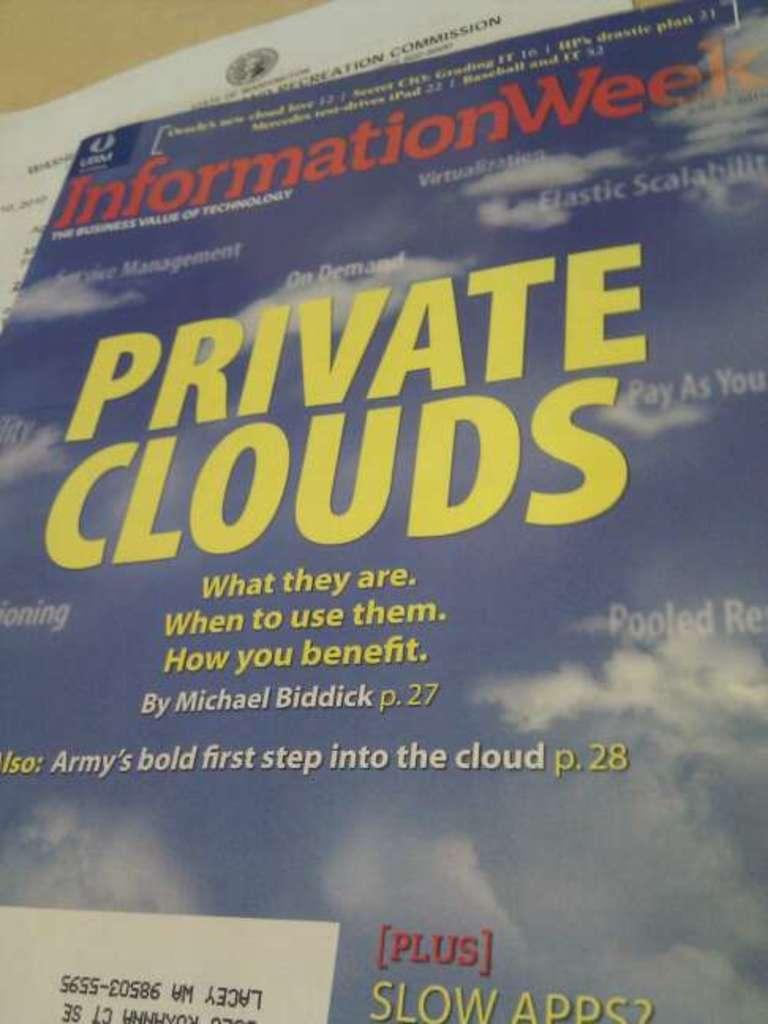<image>
Render a clear and concise summary of the photo. Information Week magazine with the words of private clouds written on it. 